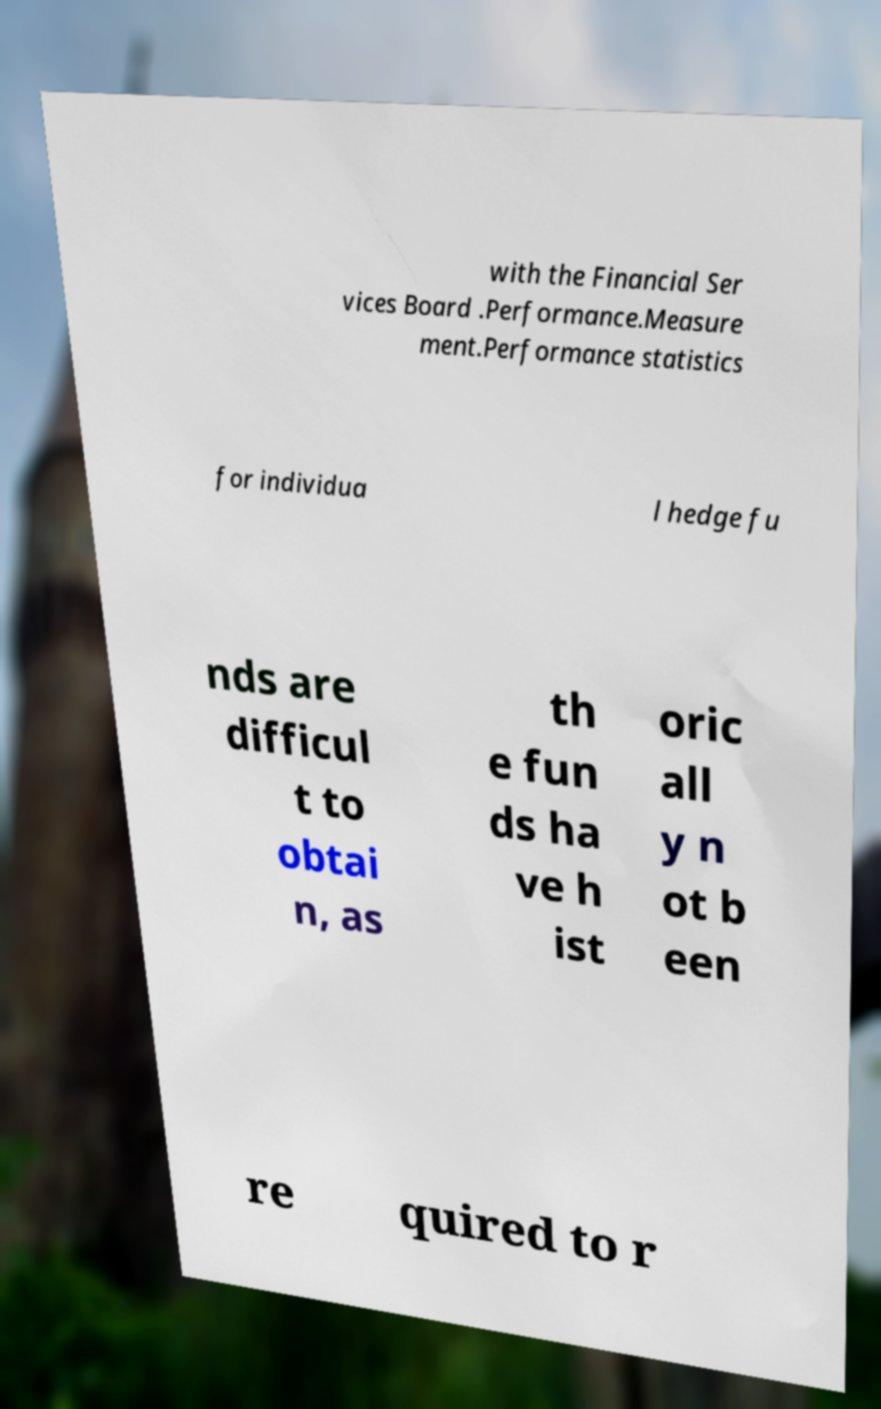Please identify and transcribe the text found in this image. with the Financial Ser vices Board .Performance.Measure ment.Performance statistics for individua l hedge fu nds are difficul t to obtai n, as th e fun ds ha ve h ist oric all y n ot b een re quired to r 